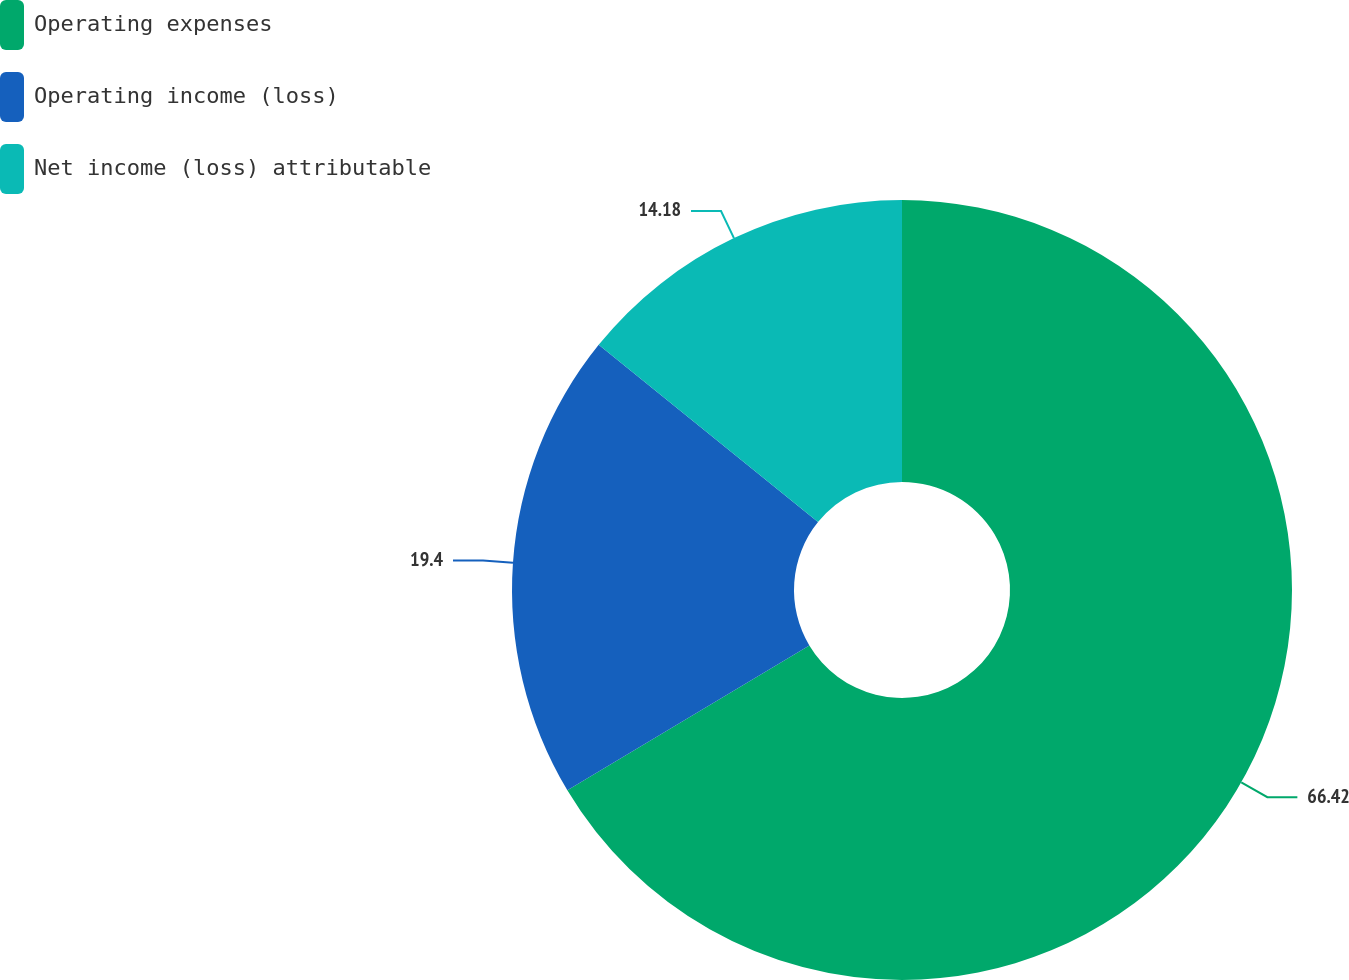<chart> <loc_0><loc_0><loc_500><loc_500><pie_chart><fcel>Operating expenses<fcel>Operating income (loss)<fcel>Net income (loss) attributable<nl><fcel>66.41%<fcel>19.4%<fcel>14.18%<nl></chart> 